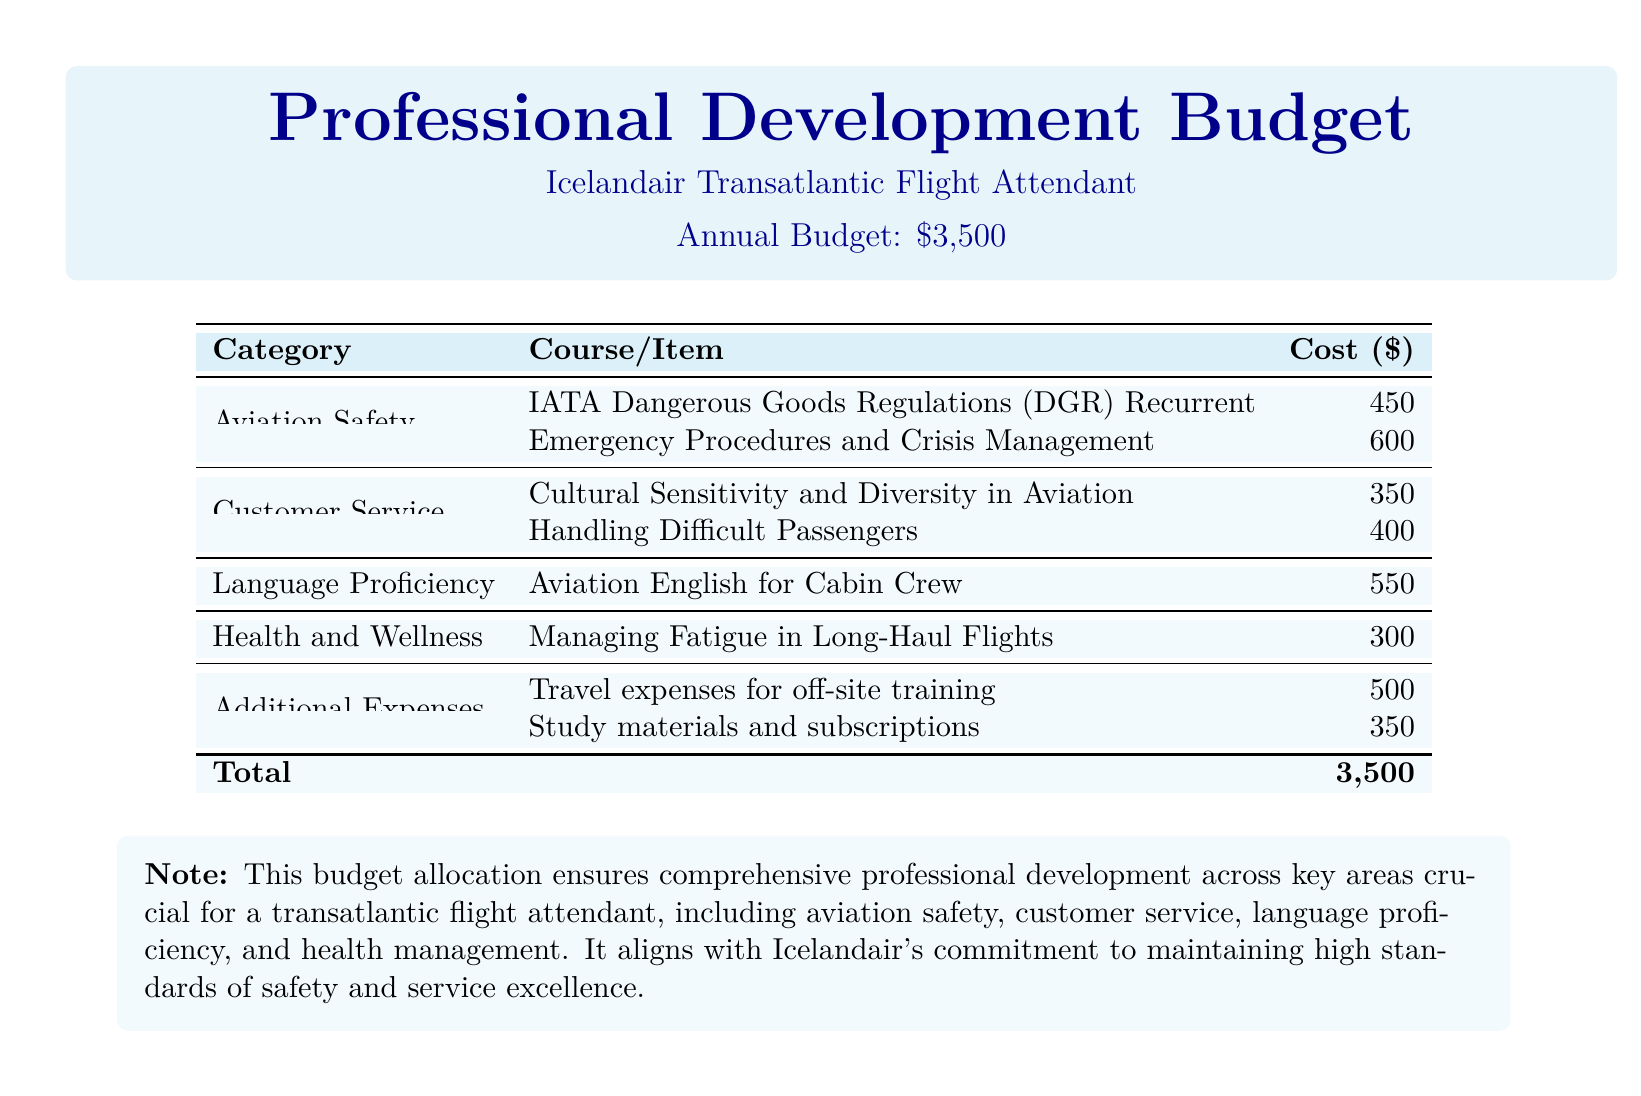What is the total budget for professional development? The total budget is clearly stated at the end of the document.
Answer: $3,500 What is the cost of the Emergency Procedures and Crisis Management course? The cost is listed under the Aviation Safety category in the table.
Answer: 600 Which course focuses on handling difficult passengers? The name of the course is given under the Customer Service category.
Answer: Handling Difficult Passengers How much is allocated for travel expenses for off-site training? The specific expense is mentioned in the Additional Expenses section of the document.
Answer: 500 What category does the course "Aviation English for Cabin Crew" belong to? The category is found in the table, labeling different training areas.
Answer: Language Proficiency What percentage of the total budget is allocated for safety courses? By examining the costs of safety courses and dividing by the total budget, we can calculate this portion.
Answer: 30% What is the cost of managing fatigue in long-haul flights? The document specifies the cost in the Health and Wellness section.
Answer: 300 How many courses are listed under Customer Service? The total number of courses is counted from the Customer Service category.
Answer: 2 What is the note emphasizing in the budget allocation? The note at the bottom explains the significance of the budget allocation for professional development.
Answer: Comprehensive professional development 